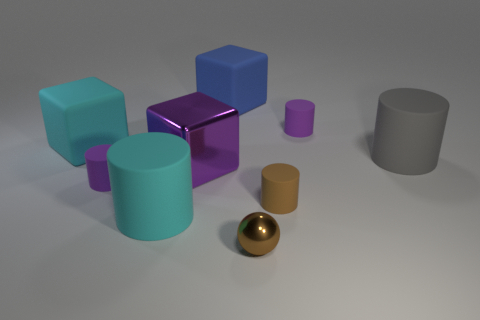Describe the material properties you observe in the different objects depicted. The objects in the image vary in their material properties. The purple cube appears to have a mirrored, highly reflective surface, suggesting a smooth, possibly metallic or plastic composition. The golden sphere also has a shiny metallic finish. The remaining objects (blue, turquoise, and gray items) exhibit a matte finish, indicating a non-reflective material like plastic or painted wood. Which object stands out the most in the image and why? The purple mirrored cube stands out the most due to its reflective mirrored finish which contrasts sharply with the matte surfaces of other objects. Its unique color and mirror-like surface create a striking visual emphasis compared to the more subdued colors and finishes around it. 